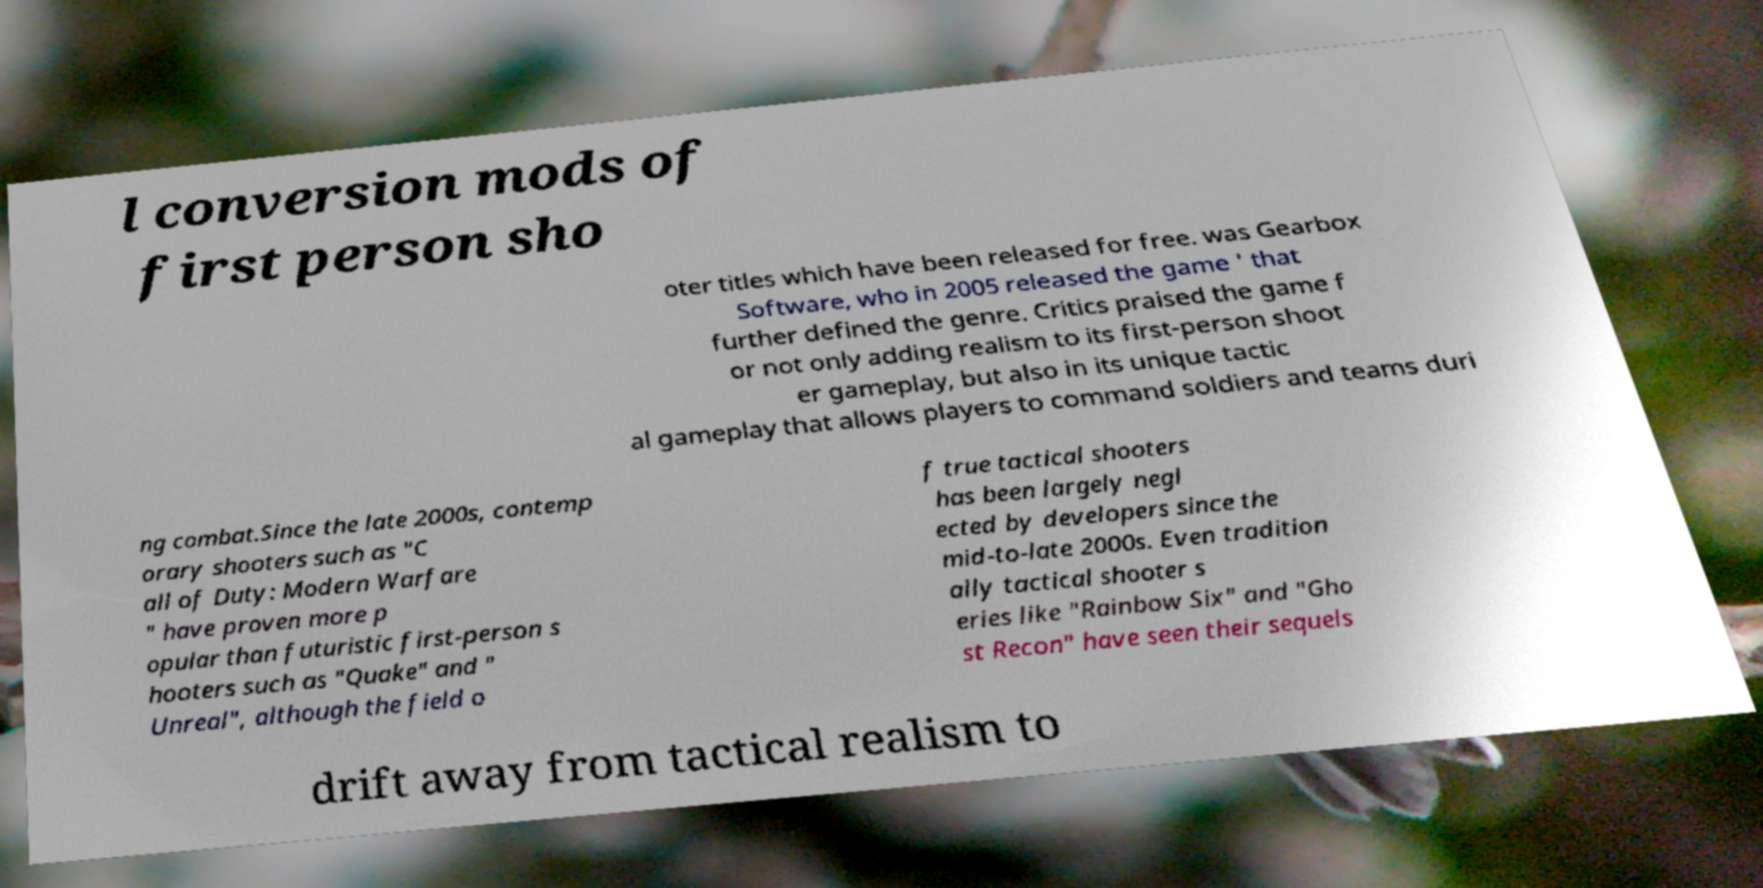Can you read and provide the text displayed in the image?This photo seems to have some interesting text. Can you extract and type it out for me? l conversion mods of first person sho oter titles which have been released for free. was Gearbox Software, who in 2005 released the game ' that further defined the genre. Critics praised the game f or not only adding realism to its first-person shoot er gameplay, but also in its unique tactic al gameplay that allows players to command soldiers and teams duri ng combat.Since the late 2000s, contemp orary shooters such as "C all of Duty: Modern Warfare " have proven more p opular than futuristic first-person s hooters such as "Quake" and " Unreal", although the field o f true tactical shooters has been largely negl ected by developers since the mid-to-late 2000s. Even tradition ally tactical shooter s eries like "Rainbow Six" and "Gho st Recon" have seen their sequels drift away from tactical realism to 